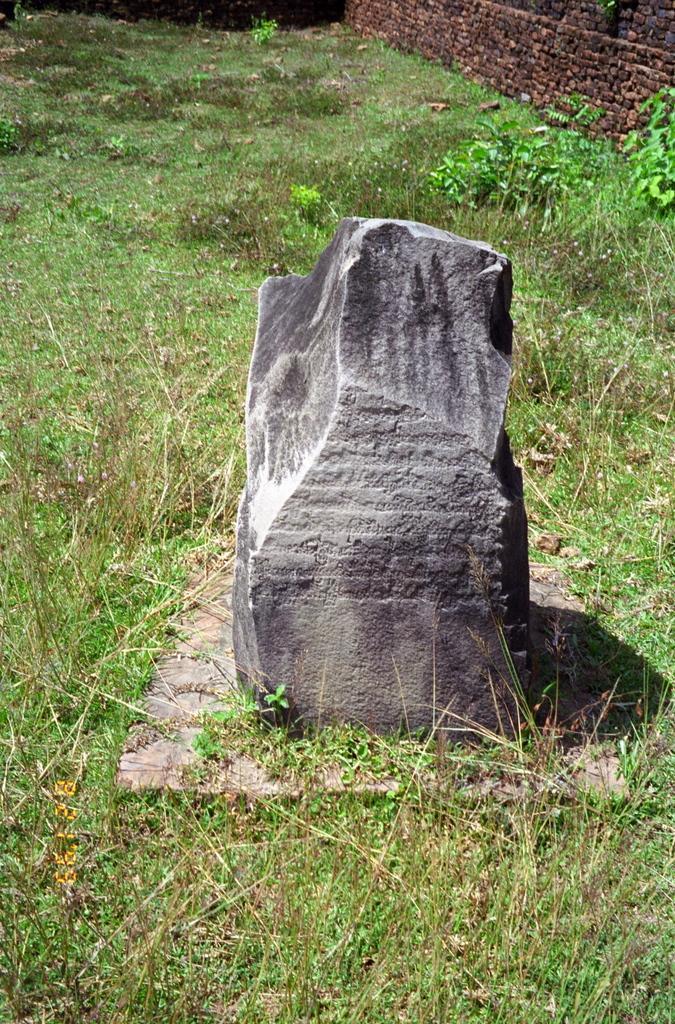How would you summarize this image in a sentence or two? In this picture we can see some grass, plants, a wall and the rock. 